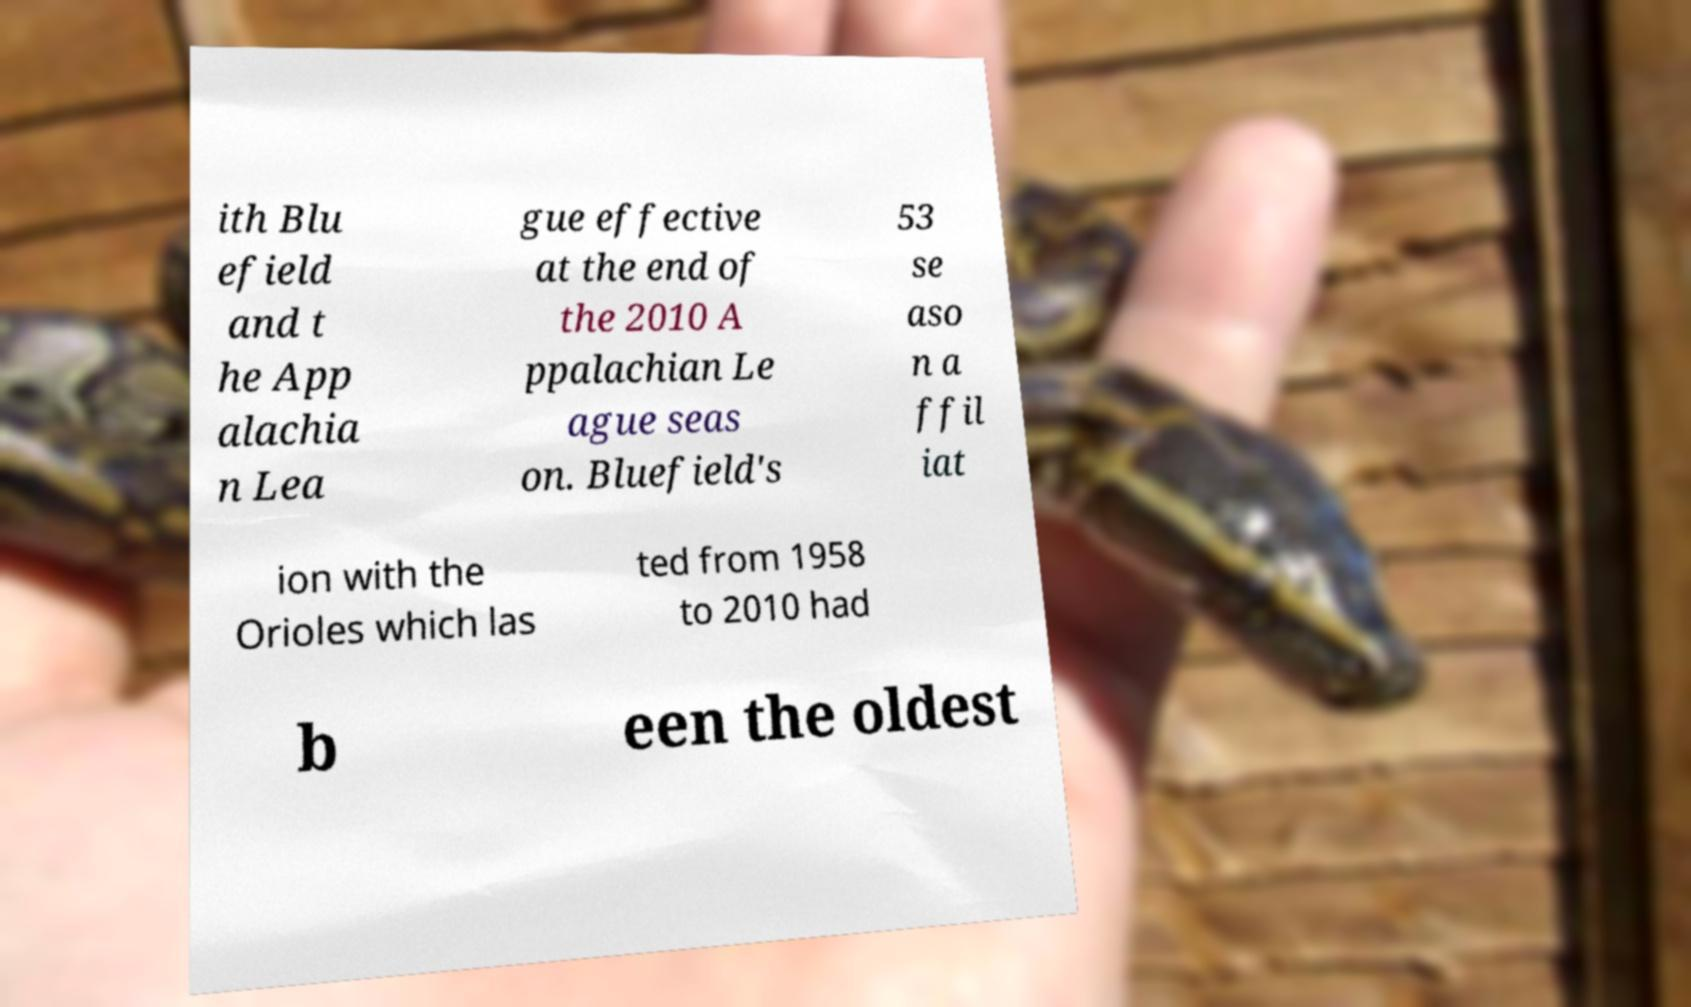For documentation purposes, I need the text within this image transcribed. Could you provide that? ith Blu efield and t he App alachia n Lea gue effective at the end of the 2010 A ppalachian Le ague seas on. Bluefield's 53 se aso n a ffil iat ion with the Orioles which las ted from 1958 to 2010 had b een the oldest 